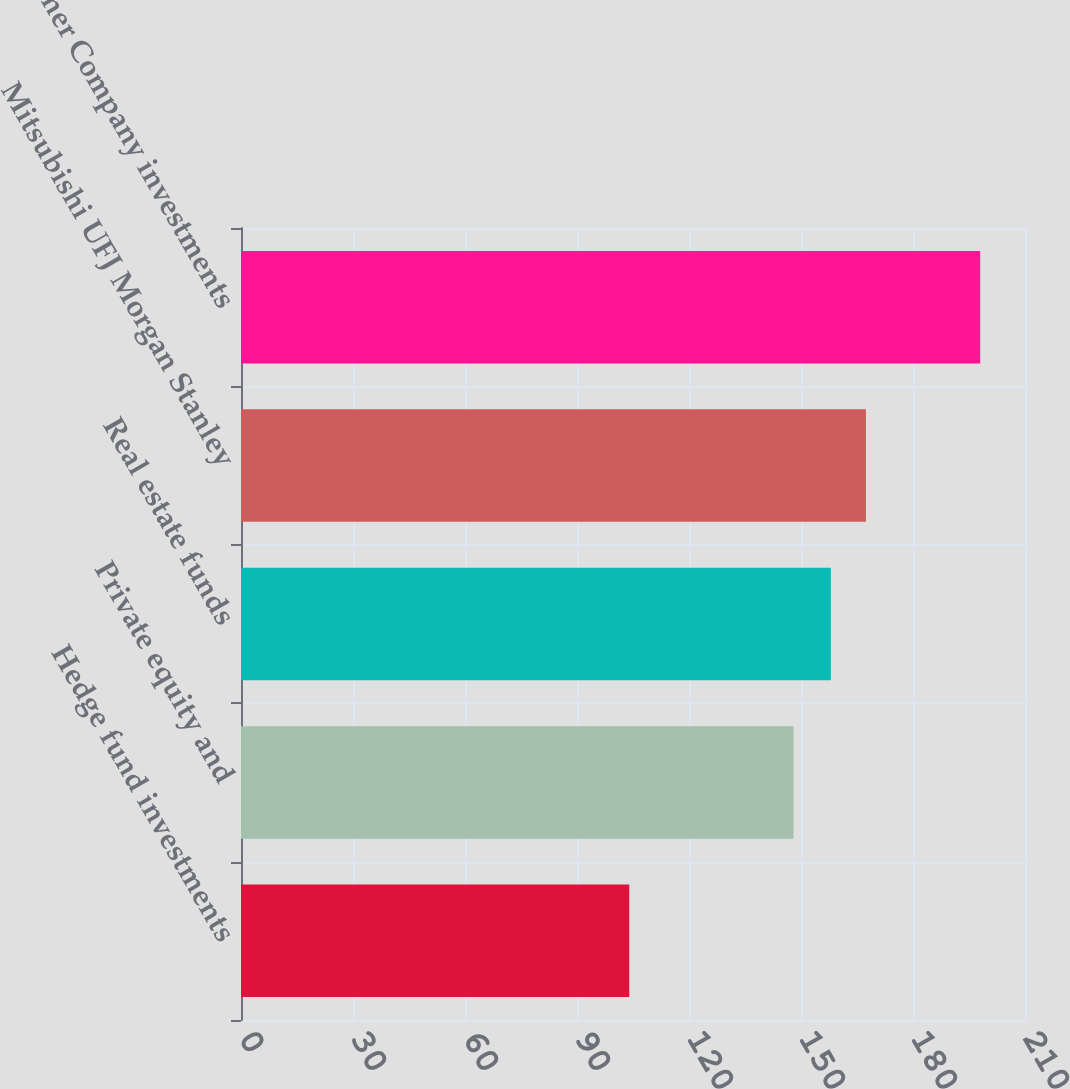<chart> <loc_0><loc_0><loc_500><loc_500><bar_chart><fcel>Hedge fund investments<fcel>Private equity and<fcel>Real estate funds<fcel>Mitsubishi UFJ Morgan Stanley<fcel>Other Company investments<nl><fcel>104<fcel>148<fcel>158<fcel>167.4<fcel>198<nl></chart> 